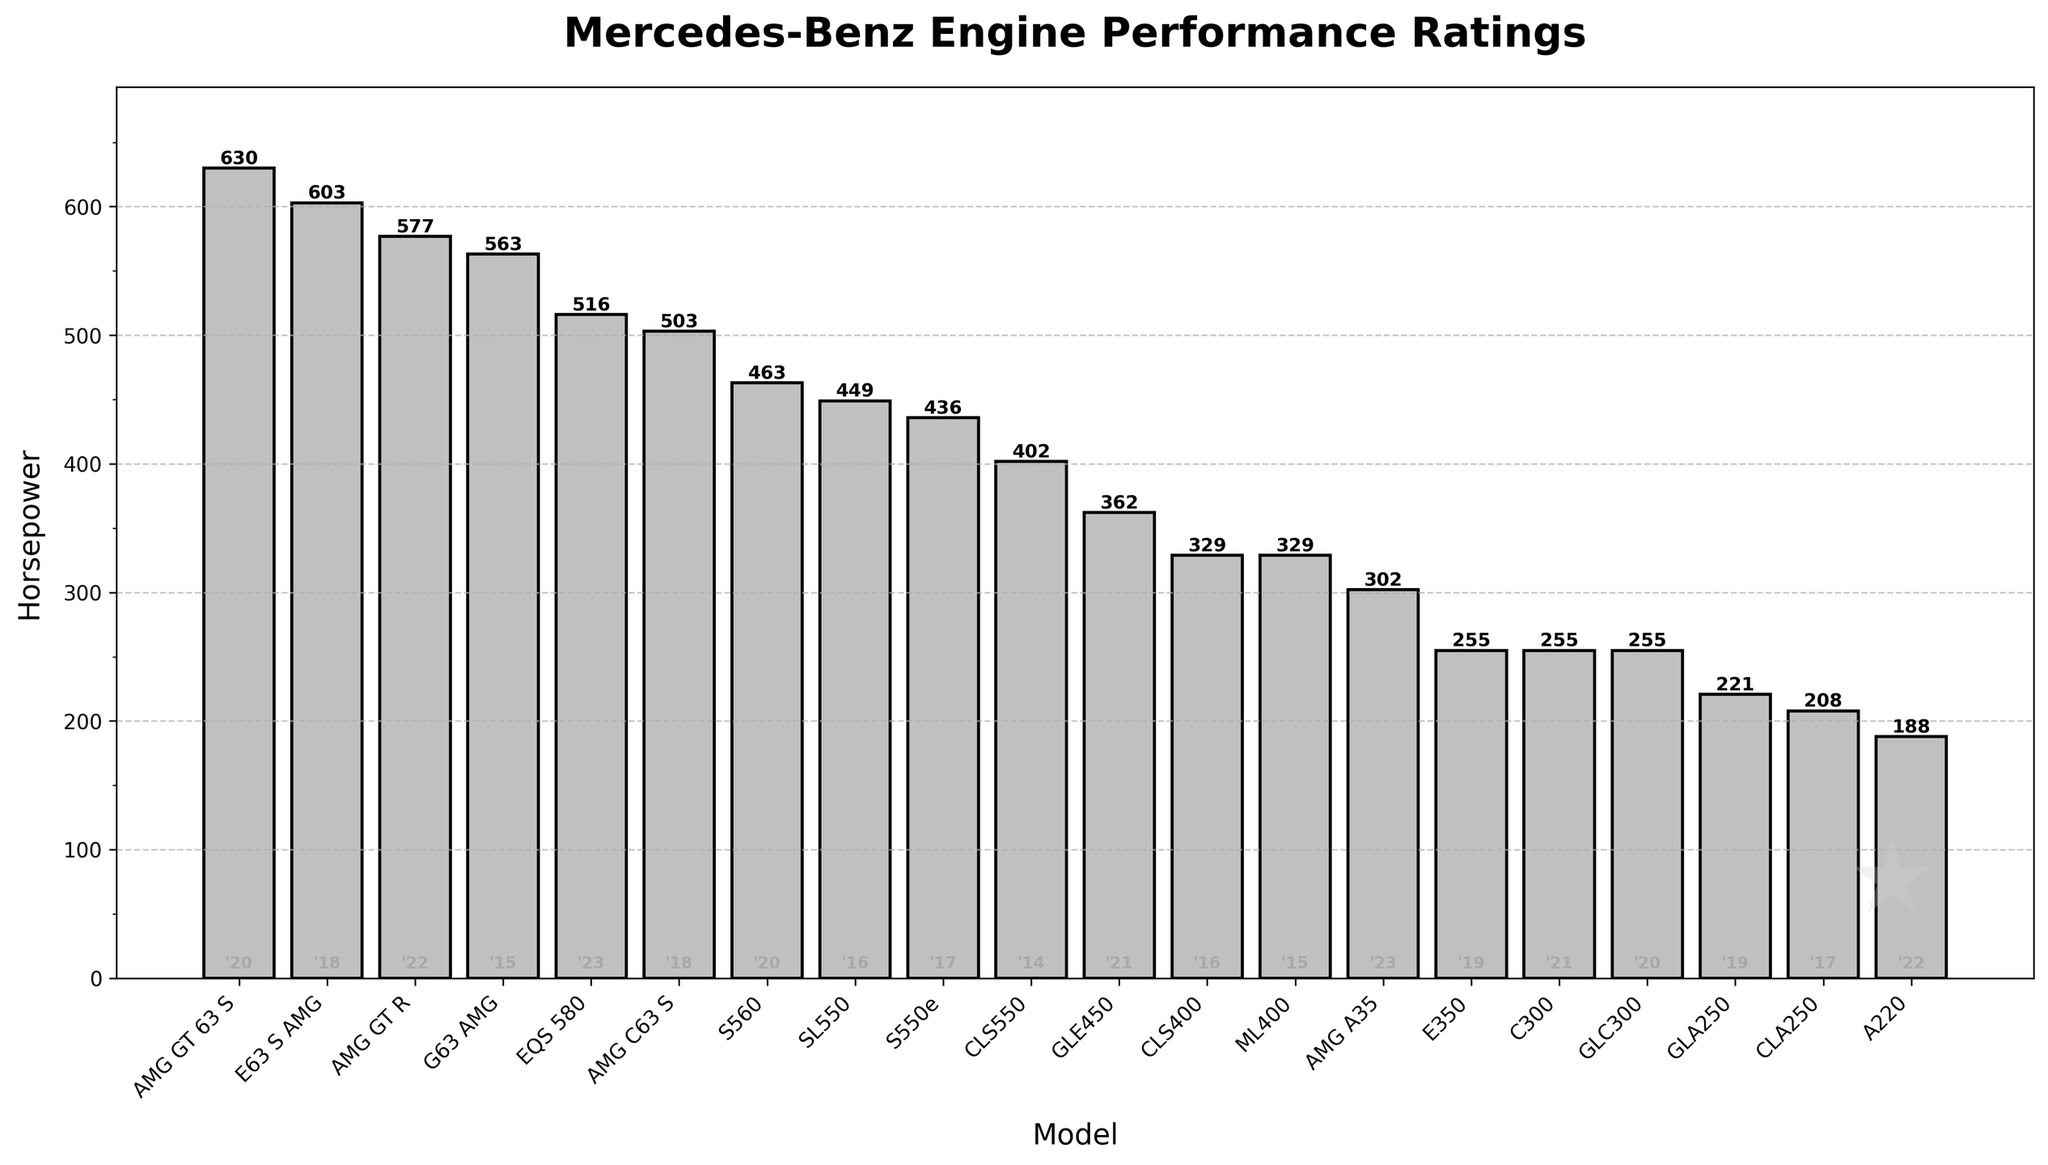Which model has the highest horsepower? Look at the model with the tallest bar in the chart, representing the highest horsepower value. The "AMG GT 63 S" from 2020 has the highest horsepower at 630.
Answer: AMG GT 63 S What is the combined horsepower of the models released in 2020? Identify and sum the horsepower values of the models from 2020: S560 (463), GLC300 (255), and AMG GT 63 S (630). The total horsepower is 463 + 255 + 630 = 1348.
Answer: 1348 Which model released in 2023 has higher horsepower, AMG A35 or EQS 580? Compare the heights of the bars for the 2023 models, EQS 580 (516) and AMG A35 (302). The EQS 580 has higher horsepower.
Answer: EQS 580 How many models have a horsepower rating above 500? Count the number of bars with a height representing a horsepower value greater than 500. These models are AMG C63 S (503), E63 S AMG (603), AMG GT R (577), EQS 580 (516), and AMG GT 63 S (630). There are 5 models.
Answer: 5 What is the average horsepower of all models released in 2019? Identify the model’s horsepower values from 2019: E350 (255) and GLA250 (221). Calculate the average: (255 + 221) / 2 = 238.
Answer: 238 Which year had the lowest average horsepower across its models? Calculate the average horsepower for each year and compare them. For example, 2014 had one model, CLS550 (402); 2015: G63 AMG (563), ML400 (329), average: (563+329)/2 = 446; continue similarly for other years. 2022 has two models, A220 (188) and AMG GT R (577), average: (188 + 577) / 2 = 382.5. The lowest is 2017: CLA250 (208) and S550e (436), average (208 + 436) / 2 = 322.
Answer: 2017 What visual element indicates the year of release for each model? The year of release is noted as a small text at the bottom of each bar, showing the last two digits of the year (e.g., '14 for 2014).
Answer: Text below the bars Which model from 2018 has the lower horsepower, AMG C63 S or E63 S AMG? Compare the heights of the bars for both 2018 models. AMG C63 S has 503 horsepower, and E63 S AMG has 603 horsepower. Therefore, AMG C63 S has lower horsepower.
Answer: AMG C63 S 